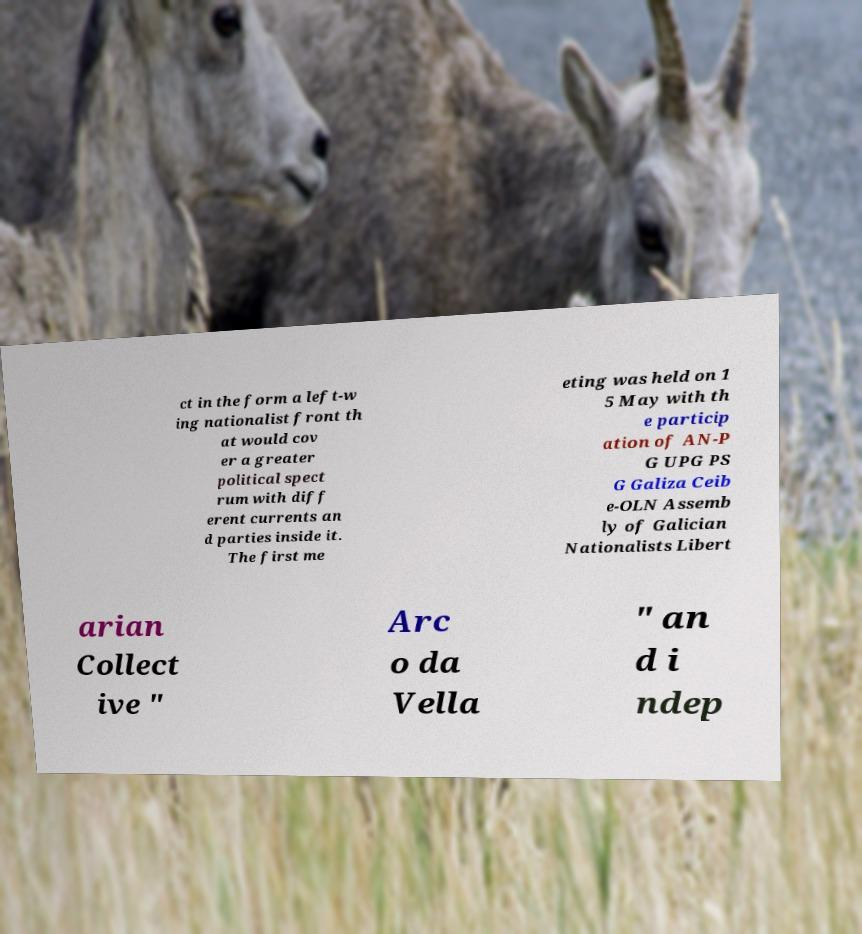Please read and relay the text visible in this image. What does it say? ct in the form a left-w ing nationalist front th at would cov er a greater political spect rum with diff erent currents an d parties inside it. The first me eting was held on 1 5 May with th e particip ation of AN-P G UPG PS G Galiza Ceib e-OLN Assemb ly of Galician Nationalists Libert arian Collect ive " Arc o da Vella " an d i ndep 